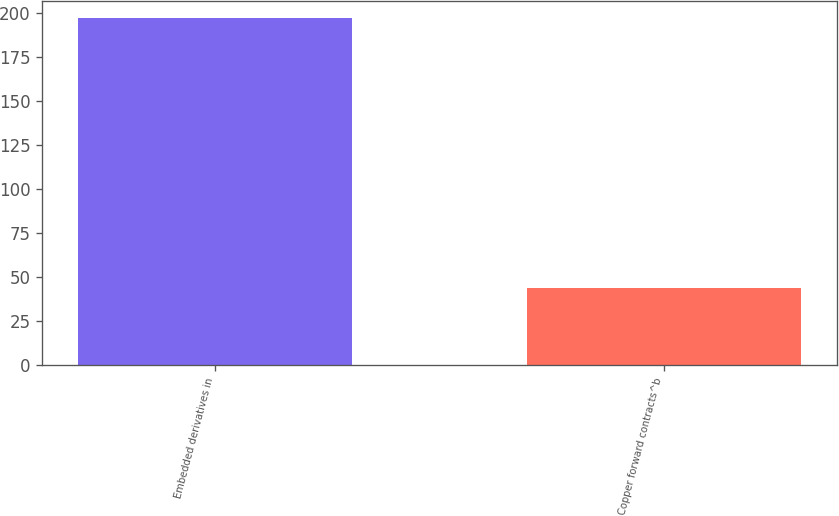<chart> <loc_0><loc_0><loc_500><loc_500><bar_chart><fcel>Embedded derivatives in<fcel>Copper forward contracts^b<nl><fcel>197<fcel>44<nl></chart> 